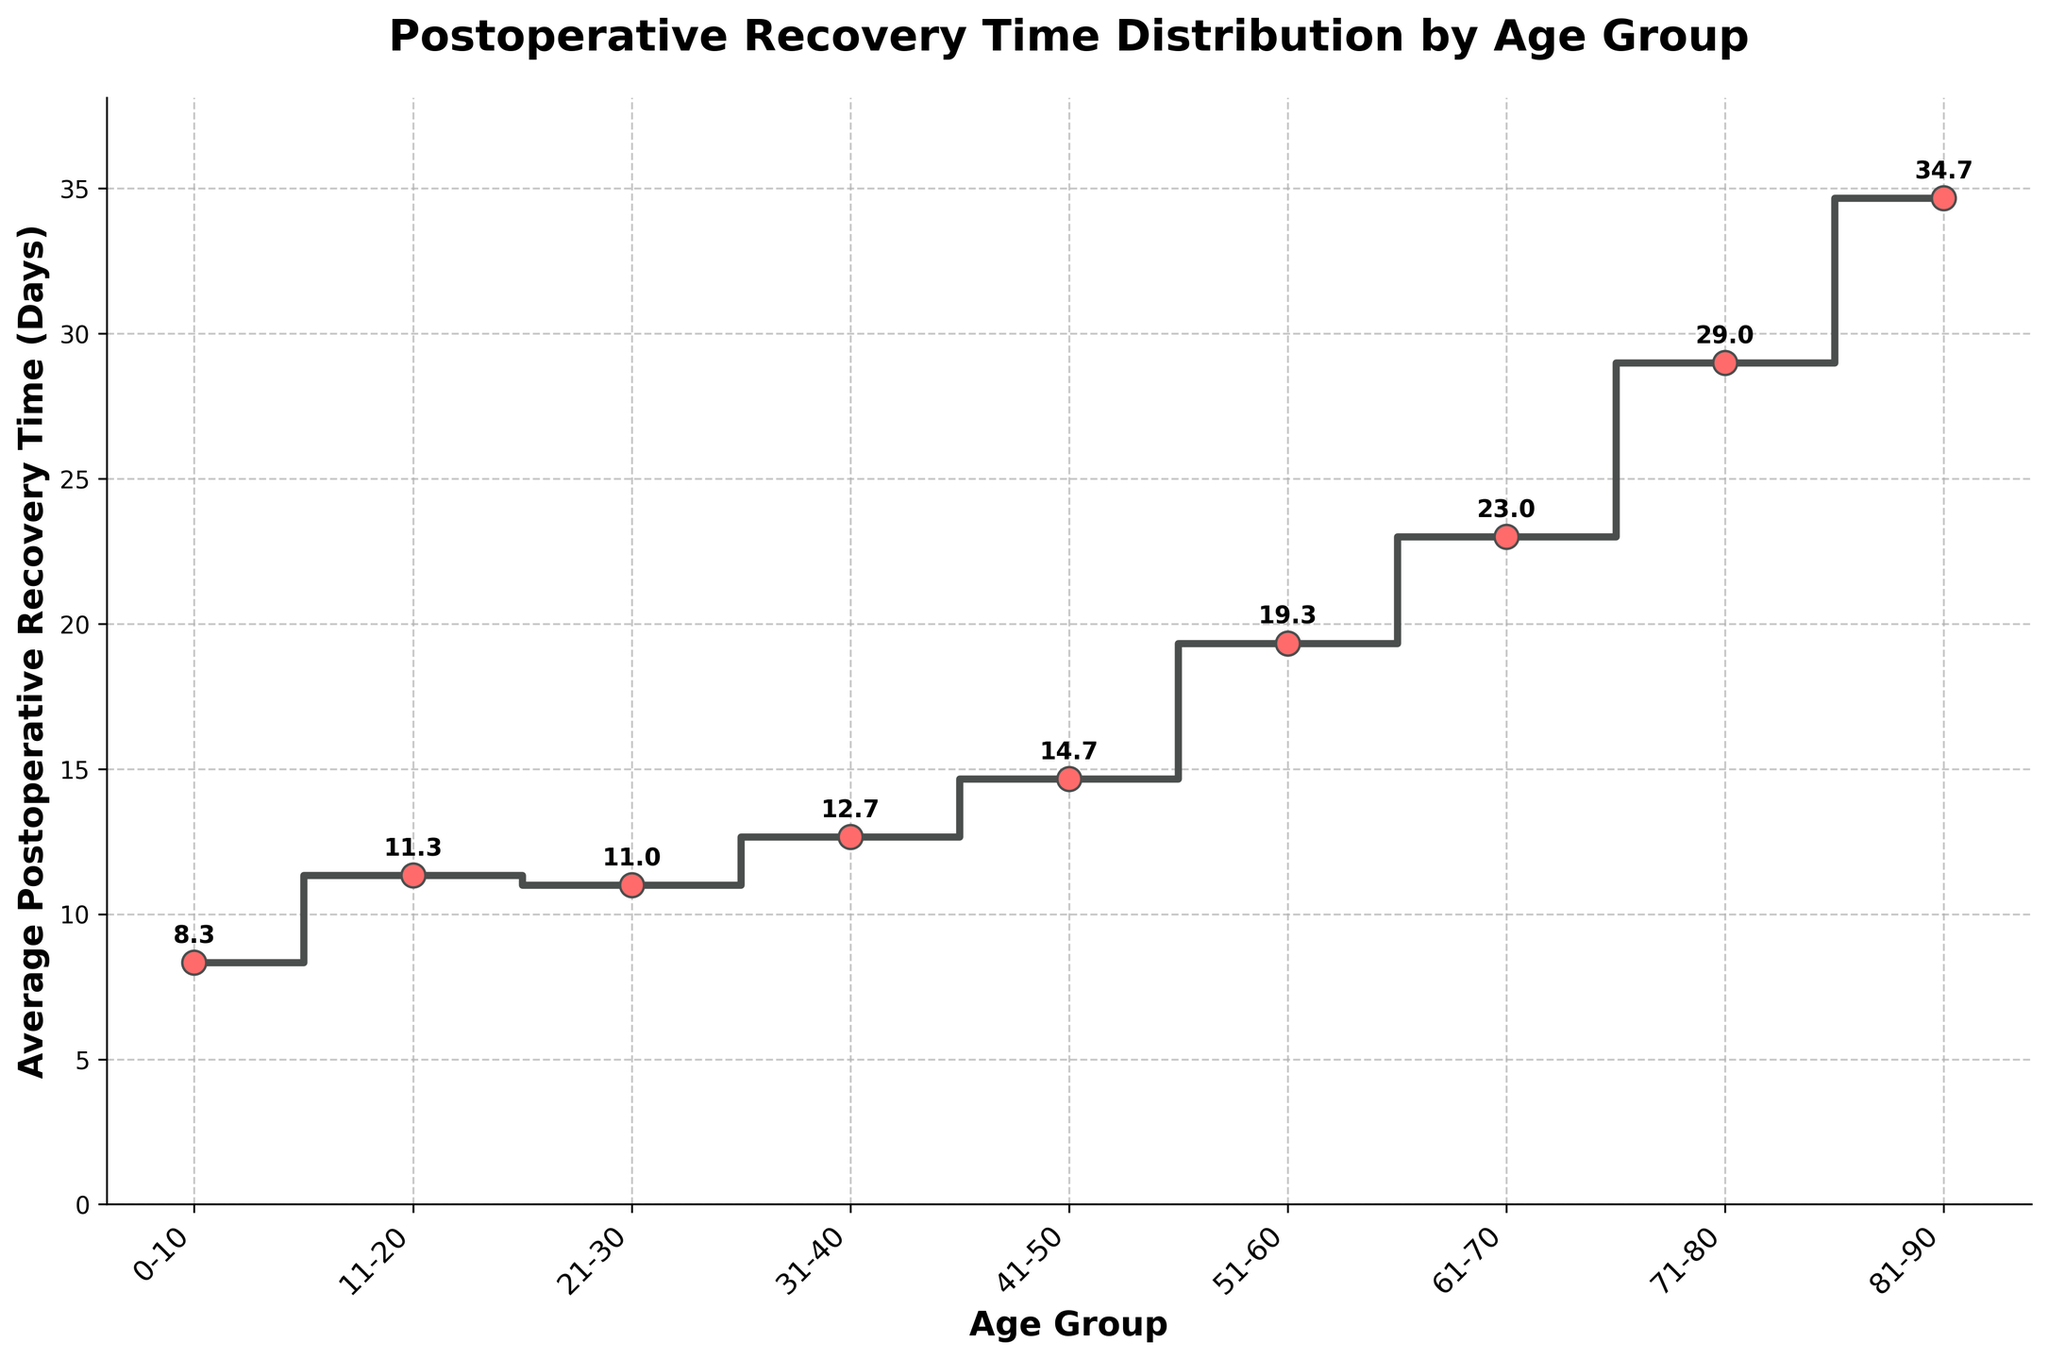What's the title of the plot? The title of the plot is displayed at the top of the figure.
Answer: Postoperative Recovery Time Distribution by Age Group What age group has the highest average recovery time? Look at the y-values associated with each age group on the x-axis. The highest point on the y-axis will indicate the highest average recovery time.
Answer: 81-90 How many age groups are shown in the plot? By counting the unique age groups displayed on the x-axis, we can determine the number of age groups.
Answer: 9 What's the average recovery time for the age group 51-60? Locate the position of the age group 51-60 on the x-axis and check the corresponding y-value. Additionally, note the numerical value displayed above the point.
Answer: 19.3 Which age group has the lowest average recovery time? Identify the age group associated with the lowest point on the y-axis to determine the lowest average recovery time.
Answer: 0-10 Is the average recovery time increasing or decreasing with age? Observe the trend of the line from left (younger age groups) to right (older age groups). An upward trend indicates increasing recovery time.
Answer: Increasing What is the difference in average recovery time between the age groups 71-80 and 81-90? Find the average recovery times for both age groups from the y-values, then subtract the average recovery time of 71-80 from that of 81-90.
Answer: 7.36 What's the recovery time for age group 31-40 relative to age group 21-30? Compare the y-values corresponding to the age groups 31-40 and 21-30 to see if one is greater than or less than the other.
Answer: Higher What's the range of average recovery times across all age groups? Calculate the difference between the highest and lowest average recovery times by finding the maximum y-value and subtracting the minimum y-value.
Answer: 30.0 - 8.33 = 21.67 Are there any age groups with equal average recovery times? Look for y-values that are the same among different age groups' points on the plot.
Answer: No 